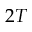Convert formula to latex. <formula><loc_0><loc_0><loc_500><loc_500>2 T</formula> 